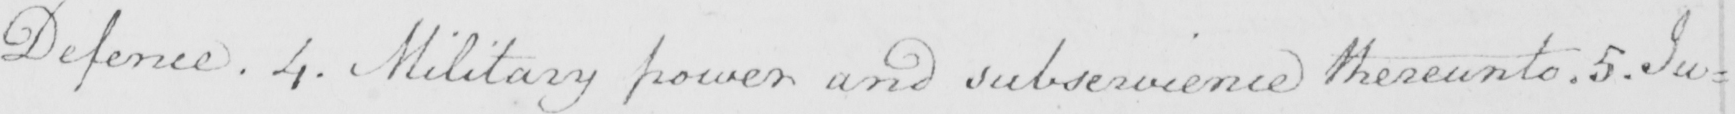Can you tell me what this handwritten text says? Defence . 4 . Military power and subservience thereunto . 5 . Ju= 